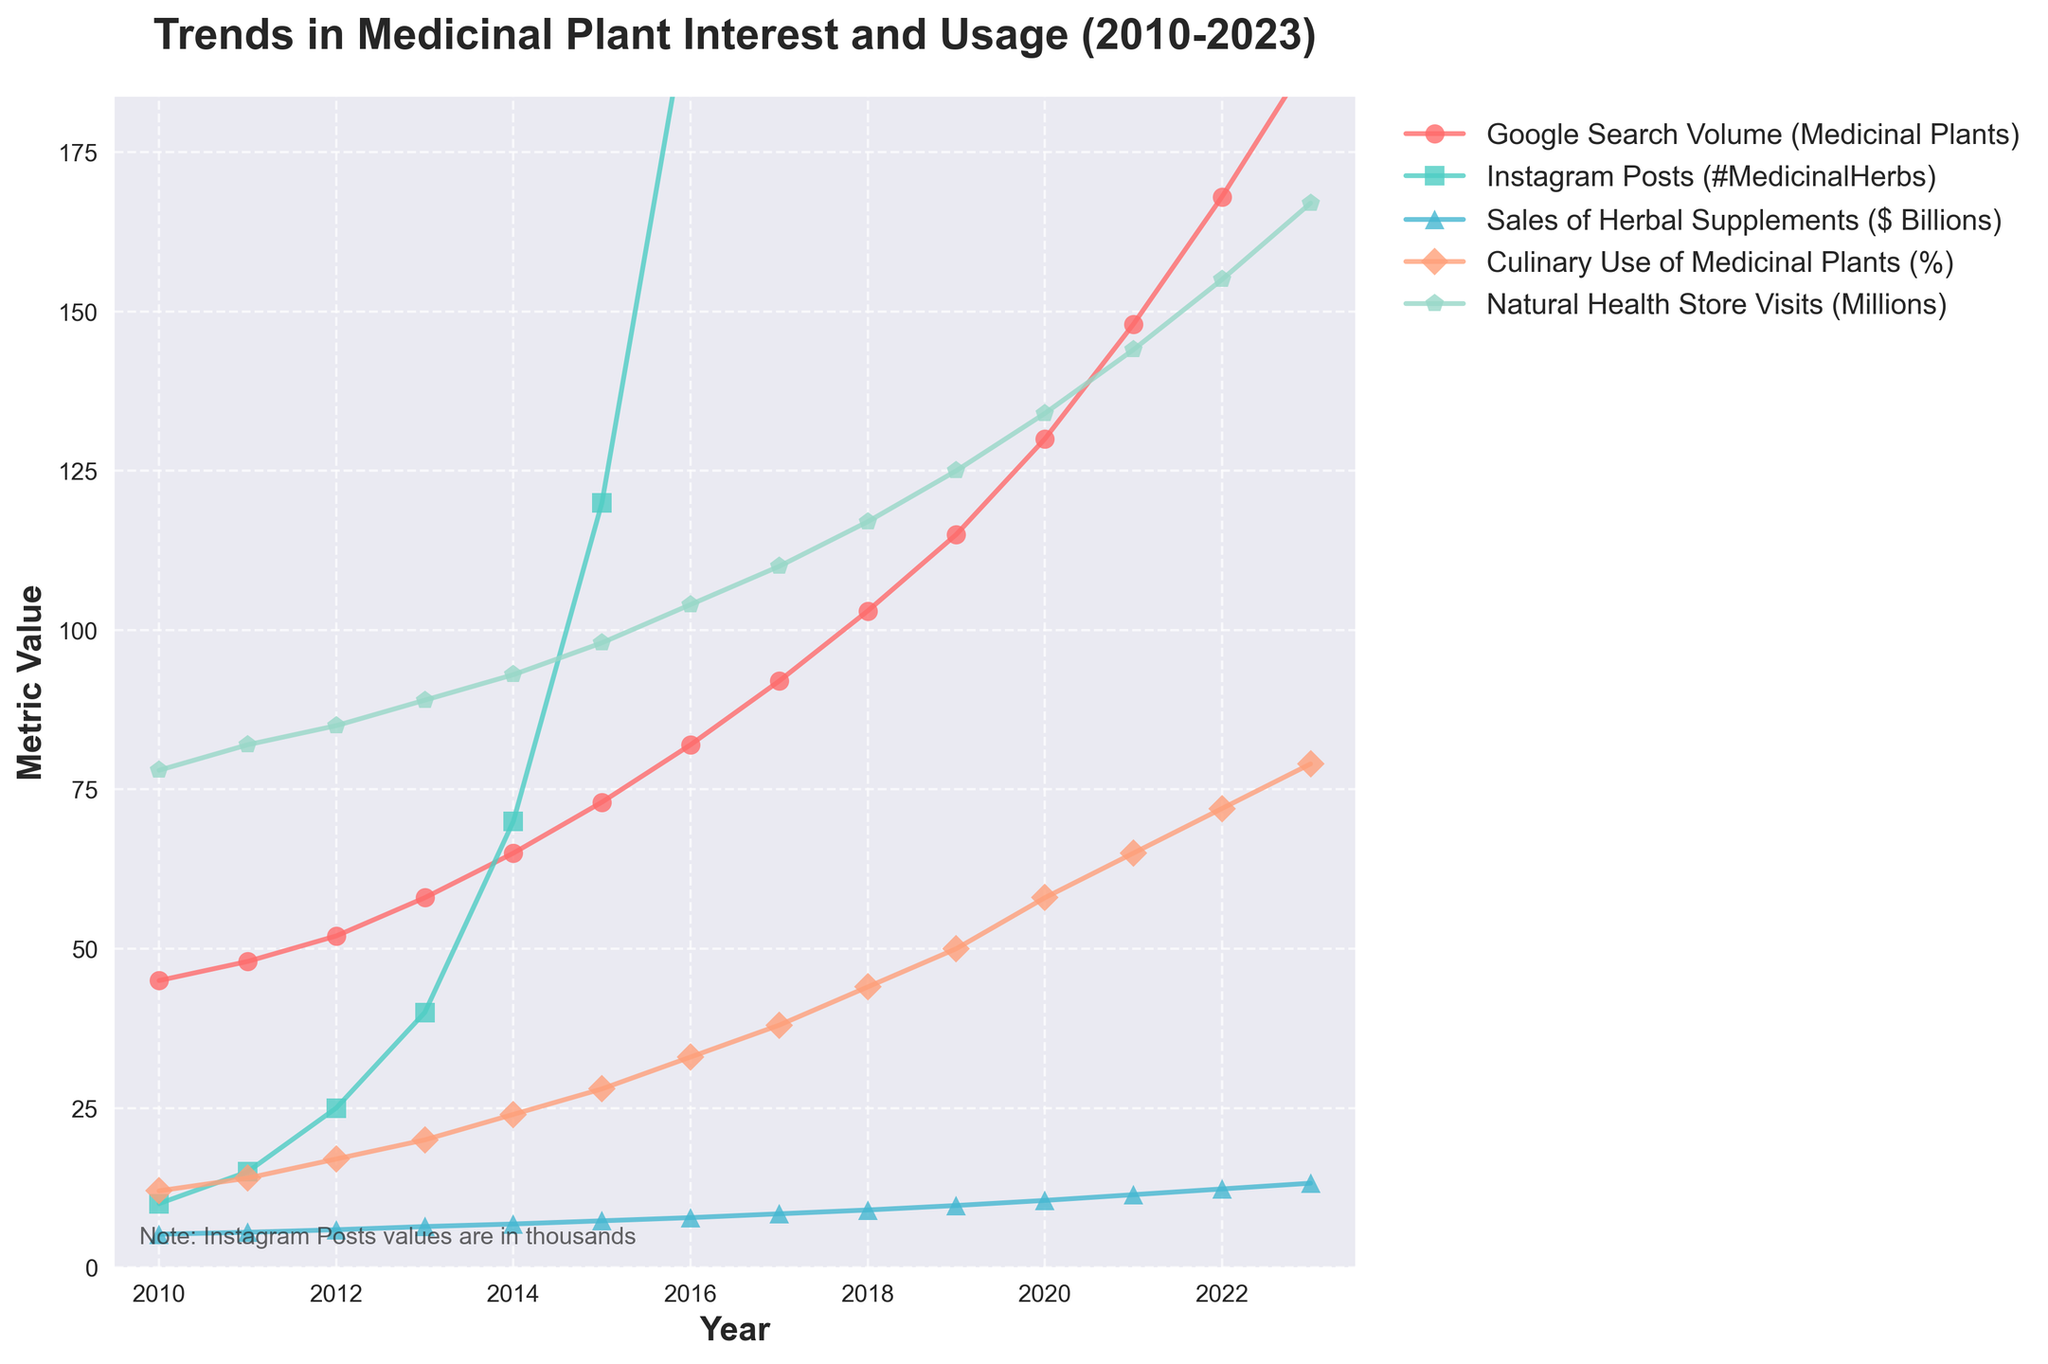What year saw the highest number of Instagram posts related to medicinal herbs? To find this, locate the peak point along the Instagram Posts line. The graph shows the highest point in the line chart for Instagram Posts is in 2023.
Answer: 2023 How has the sales of herbal supplements changed from 2010 to 2023? Identify the initiation and termination points for the Sales of Herbal Supplements line. The line starts at $5.2 billion in 2010 and ends at $13.2 billion in 2023, reflecting an increase of $8 billion.
Answer: Increased by $8 billion In 2021, which metric saw the highest value, and what was it? Compare the five metric lines at the year 2021. The highest value line at 2021 is for Natural Health Store Visits (Millions), the value being 144 million.
Answer: Natural Health Store Visits (144 million) What is the average percentage of Culinary Use of Medicinal Plants from 2010 to 2023? Sum the percentages for each year and divide by the number of years. The calculation involves summing up 12+14+17+20+24+28+33+38+44+50+58+65+72+79 and then dividing by 14. Sum is 554, so the average is 554 / 14 = 39.57%.
Answer: 39.57% Which metric exhibited the most rapid growth over the given period? Observe the steepest line over the period from 2010 to 2023. Comparing the slopes, Instagram Posts (#MedicinalHerbs) exhibits the most rapid growth, going from 10,000 posts in 2010 to 3,500,000 posts in 2023.
Answer: Instagram Posts By how much did the Natural Health Store Visits increase from 2018 to 2023? Note Natural Health Store Visits at 2018 and 2023 years. Subtract Natural Health Store Visits value at 2018 from 2023: 167 million in 2023 minus 117 million in 2018. Thus, it increased by 50 million.
Answer: Increased by 50 million What year did Google Search Volume for Medicinal Plants first exceed 100? Find the year when the Google Search Volume line first rises above 100. The search volume first exceeds 100 in 2018 as it reaches 103.
Answer: 2018 In which year did all metrics show consistent upward trends without any decline? Identify a year where each metric line has progressed upward from previous year without any of the lines declining. Observing the trends, the year 2023 is the final data point showing all metrics in an upward direction consistently.
Answer: 2023 